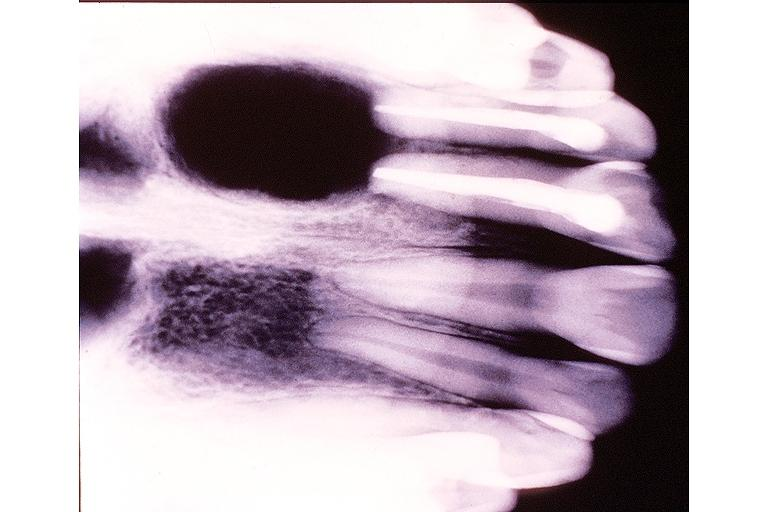where is this?
Answer the question using a single word or phrase. Oral 